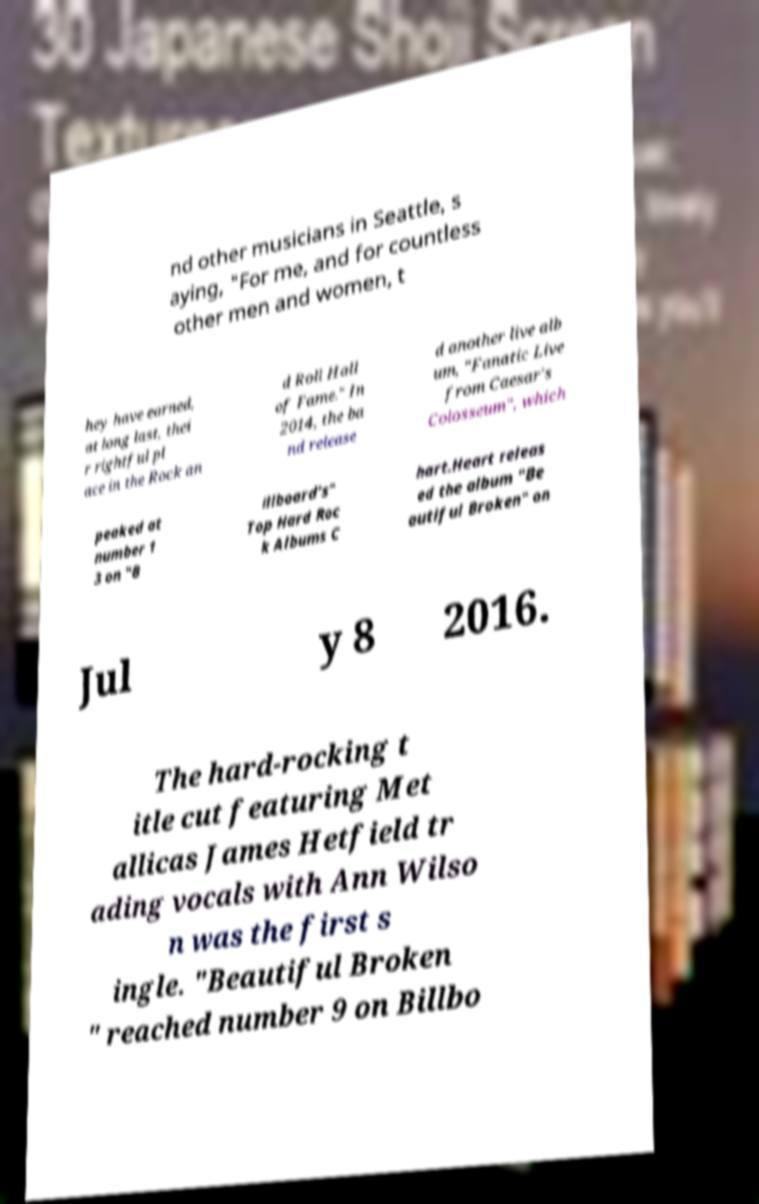There's text embedded in this image that I need extracted. Can you transcribe it verbatim? nd other musicians in Seattle, s aying, "For me, and for countless other men and women, t hey have earned, at long last, thei r rightful pl ace in the Rock an d Roll Hall of Fame." In 2014, the ba nd release d another live alb um, "Fanatic Live from Caesar's Colosseum", which peaked at number 1 3 on "B illboard's" Top Hard Roc k Albums C hart.Heart releas ed the album "Be autiful Broken" on Jul y 8 2016. The hard-rocking t itle cut featuring Met allicas James Hetfield tr ading vocals with Ann Wilso n was the first s ingle. "Beautiful Broken " reached number 9 on Billbo 